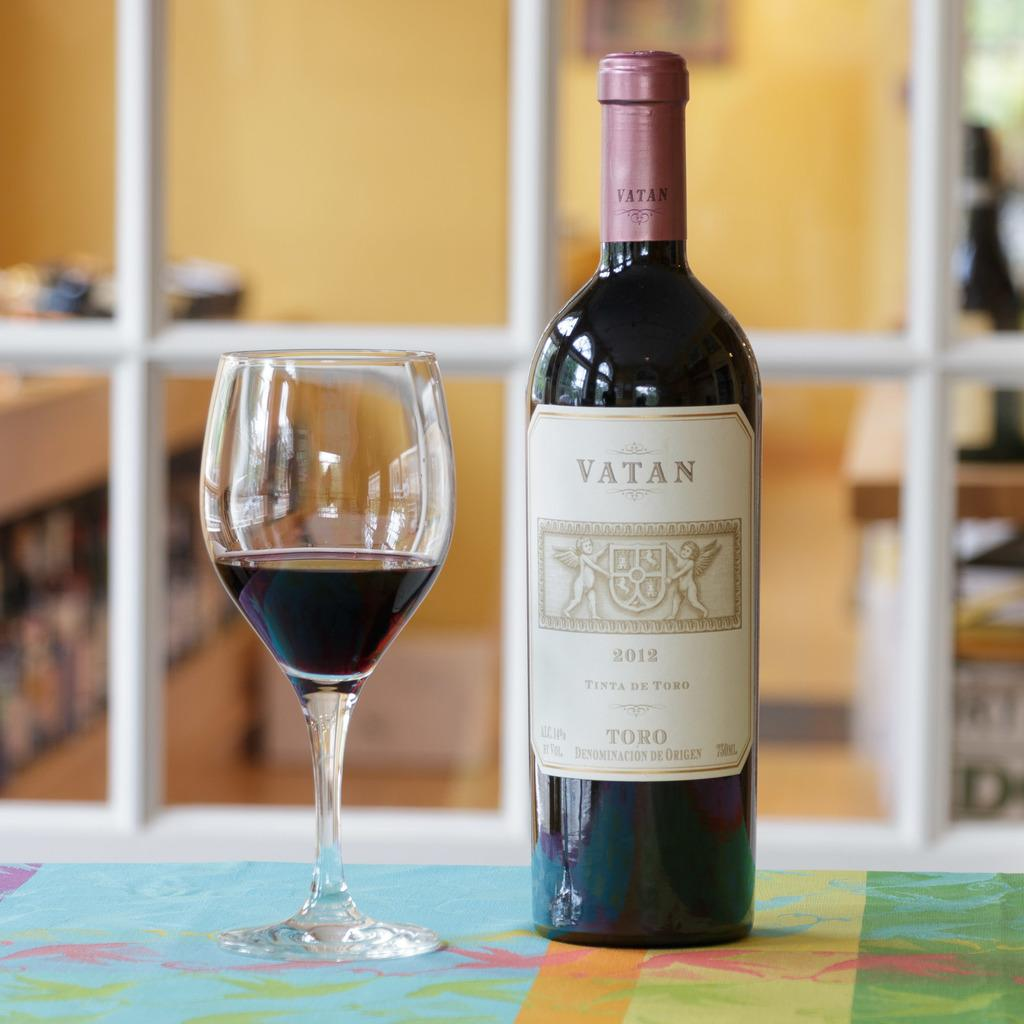What objects are on the table in the image? There is a bottle and a glass on the table in the image. What can be found on the bottle? There is writing on the label of the bottle. How is the background of the image depicted? The background of the image is blurred. What type of instrument is being played in the background of the image? There is no instrument being played in the background of the image. Can you describe the pickle that is being served with the glass in the image? There is no pickle present in the image. 